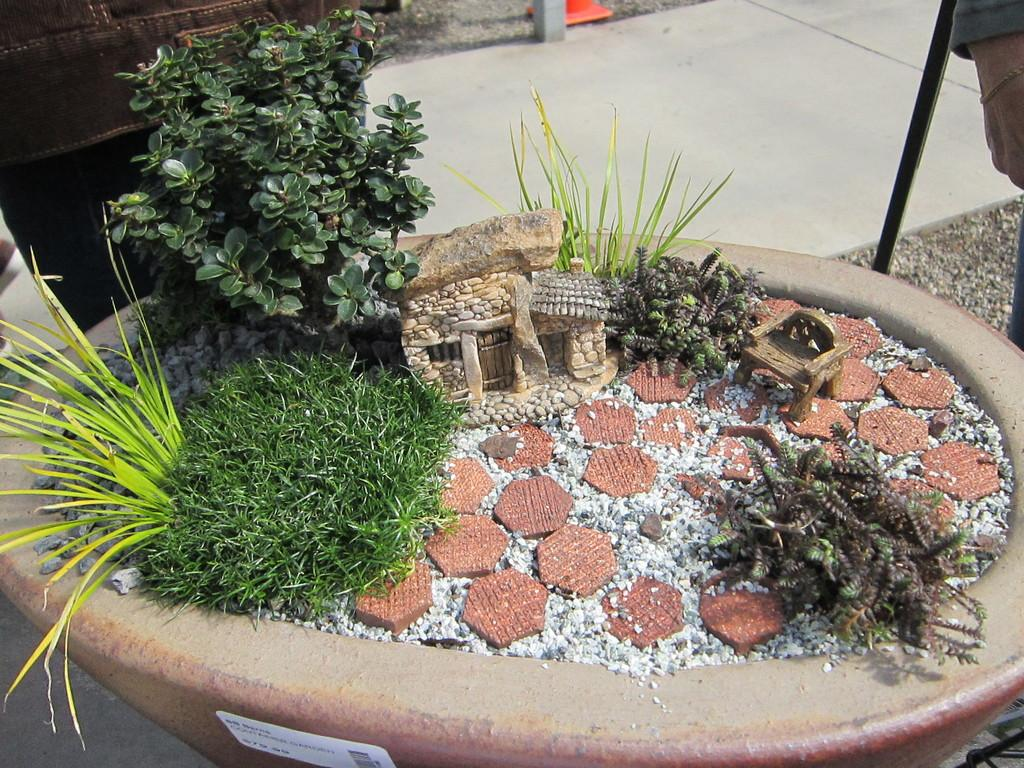What is the main subject in the middle of the picture? There is a scale model of a stone house in the middle of the picture. What can be seen on the left side of the picture? There are plants on the left side of the picture. What is visible in the background of the picture? There is a floor visible in the background of the picture. How many brothers are present in the picture? There is no reference to a brother or any family members in the image, so it is not possible to answer that question. 